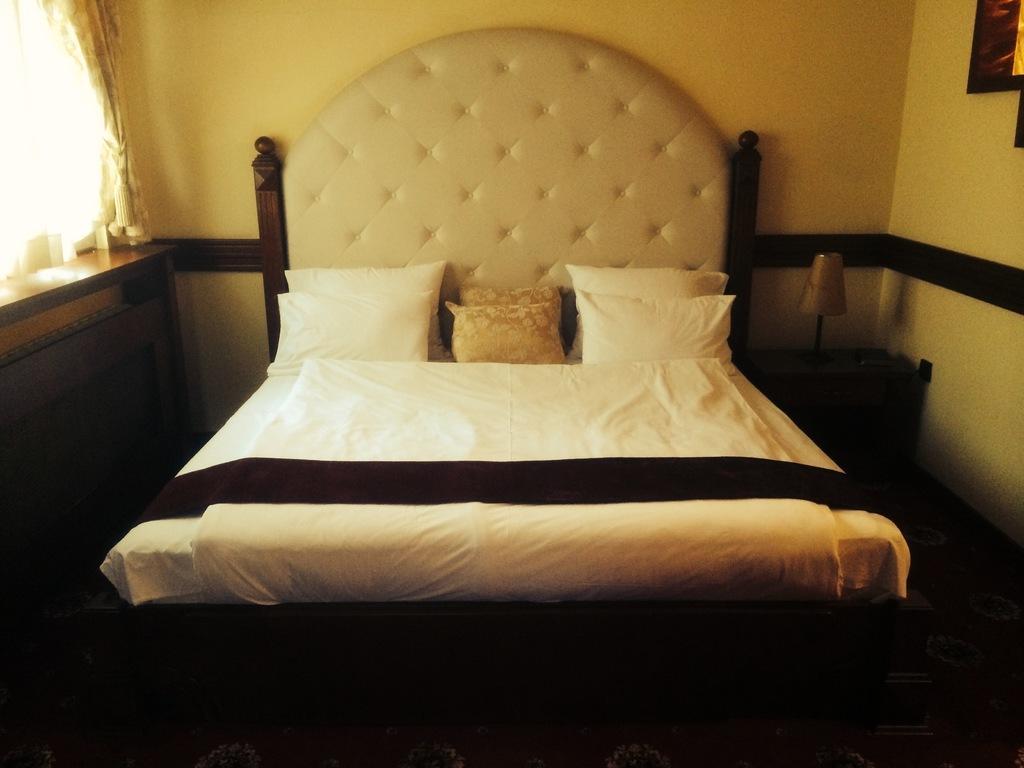Please provide a concise description of this image. This is a room. In this room there is a bed. On the bed there are pillows. On the right side there is a table. On that there is a table lamp. On the left side there is another table. Near to that there is curtain. In the back there's a wall. 